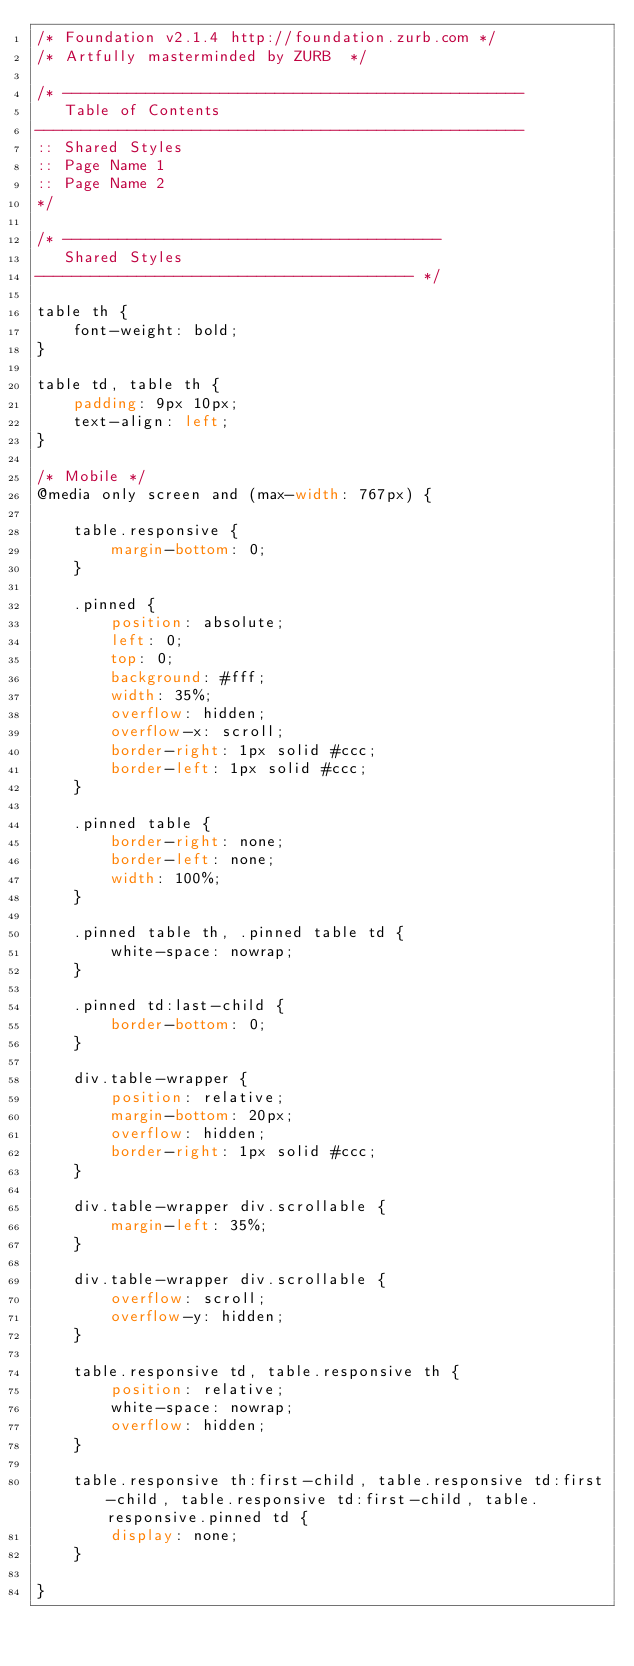<code> <loc_0><loc_0><loc_500><loc_500><_CSS_>/* Foundation v2.1.4 http://foundation.zurb.com */
/* Artfully masterminded by ZURB  */

/* --------------------------------------------------
   Table of Contents
-----------------------------------------------------
:: Shared Styles
:: Page Name 1
:: Page Name 2
*/

/* -----------------------------------------
   Shared Styles
----------------------------------------- */

table th {
    font-weight: bold;
}

table td, table th {
    padding: 9px 10px;
    text-align: left;
}

/* Mobile */
@media only screen and (max-width: 767px) {

    table.responsive {
        margin-bottom: 0;
    }

    .pinned {
        position: absolute;
        left: 0;
        top: 0;
        background: #fff;
        width: 35%;
        overflow: hidden;
        overflow-x: scroll;
        border-right: 1px solid #ccc;
        border-left: 1px solid #ccc;
    }

    .pinned table {
        border-right: none;
        border-left: none;
        width: 100%;
    }

    .pinned table th, .pinned table td {
        white-space: nowrap;
    }

    .pinned td:last-child {
        border-bottom: 0;
    }

    div.table-wrapper {
        position: relative;
        margin-bottom: 20px;
        overflow: hidden;
        border-right: 1px solid #ccc;
    }

    div.table-wrapper div.scrollable {
        margin-left: 35%;
    }

    div.table-wrapper div.scrollable {
        overflow: scroll;
        overflow-y: hidden;
    }

    table.responsive td, table.responsive th {
        position: relative;
        white-space: nowrap;
        overflow: hidden;
    }

    table.responsive th:first-child, table.responsive td:first-child, table.responsive td:first-child, table.responsive.pinned td {
        display: none;
    }

}
</code> 